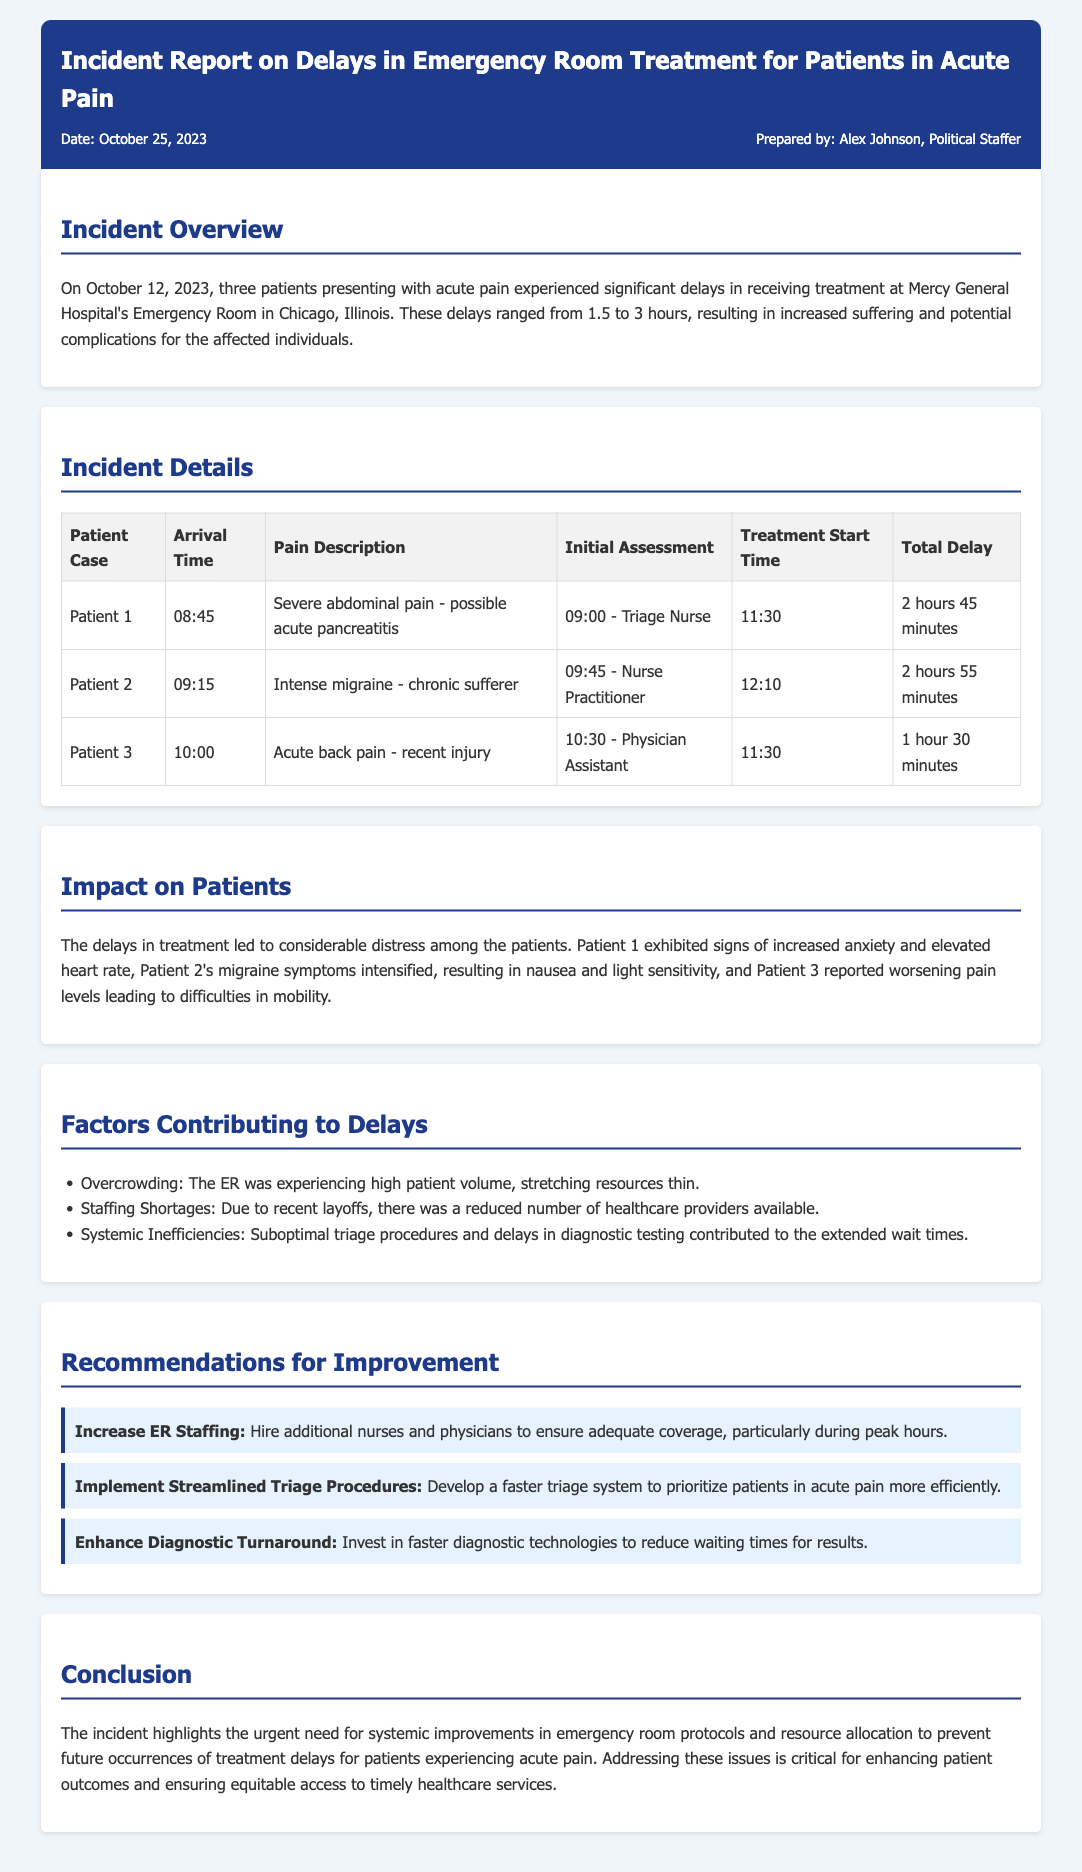What date did the incident occur? The incident occurred on October 12, 2023, as stated in the overview section of the report.
Answer: October 12, 2023 How long was the delay for Patient 2? The total delay for Patient 2 is provided in the table under the "Total Delay" column.
Answer: 2 hours 55 minutes What was the pain description for Patient 1? The pain description for Patient 1 is detailed in the incident details table.
Answer: Severe abdominal pain - possible acute pancreatitis What was one of the factors contributing to the delays? The document lists multiple factors in the "Factors Contributing to Delays" section, one being overcrowding.
Answer: Overcrowding What recommendation is made to improve ER treatment? Recommendations for improvement are provided, including increasing ER staffing.
Answer: Increase ER Staffing 